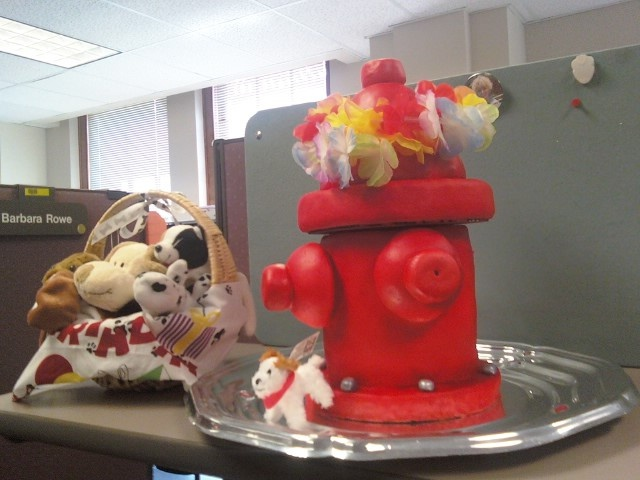Describe the objects in this image and their specific colors. I can see fire hydrant in darkgray, brown, maroon, and salmon tones, teddy bear in darkgray, tan, black, and gray tones, dog in darkgray, tan, lightgray, and brown tones, and dog in darkgray, black, beige, and gray tones in this image. 